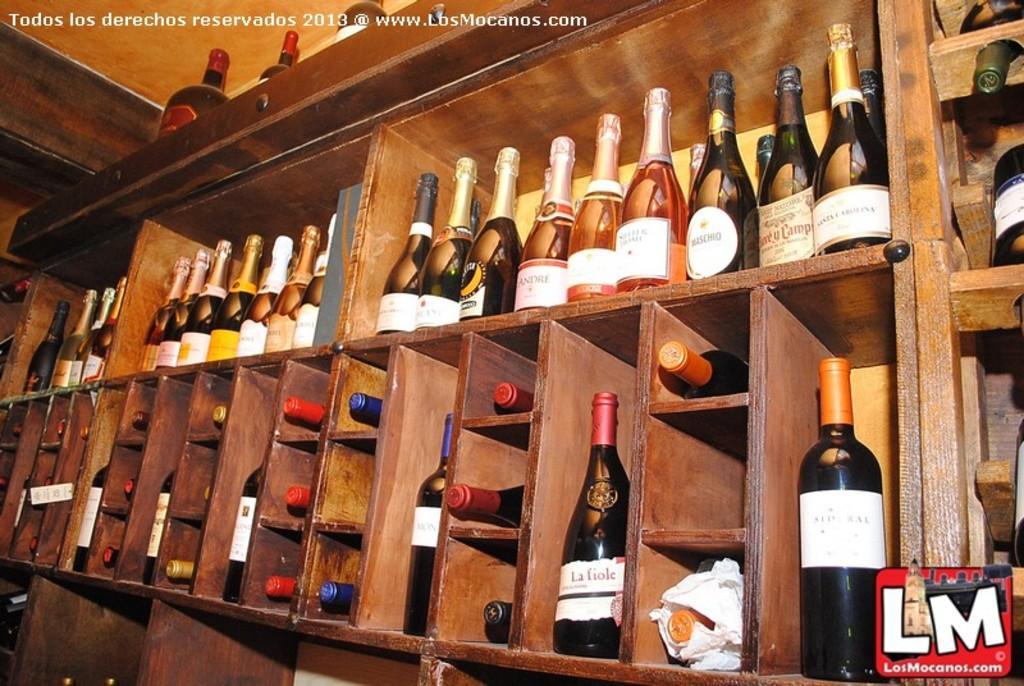How would you summarize this image in a sentence or two? The image consists of wine bottles which are kept in the wooden shelves. 